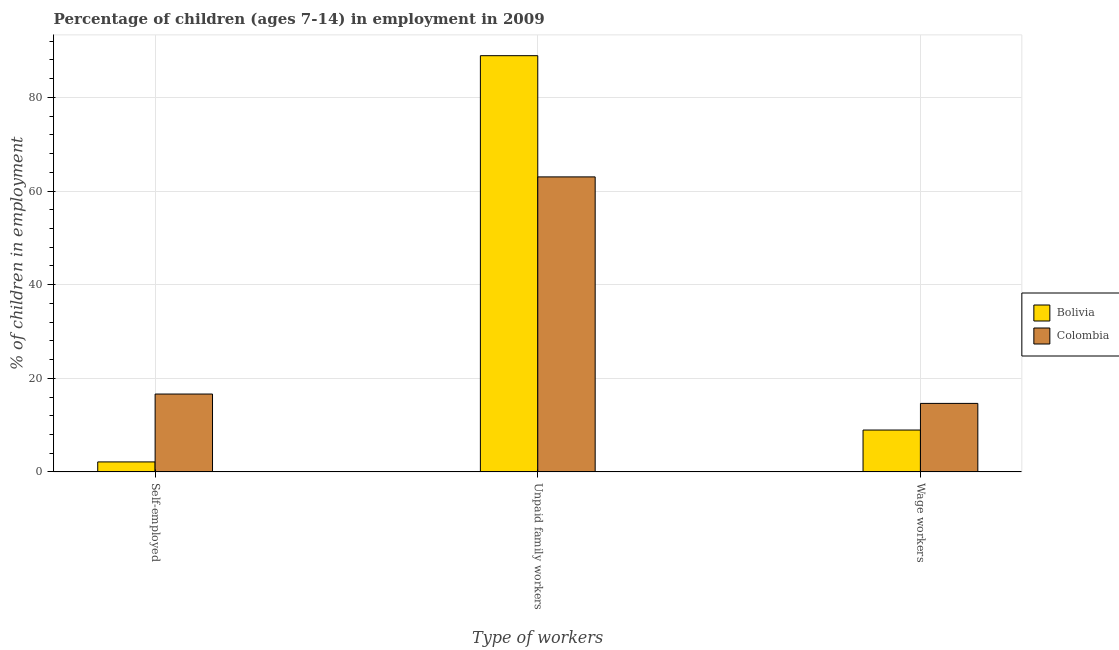How many different coloured bars are there?
Provide a succinct answer. 2. How many bars are there on the 1st tick from the left?
Offer a terse response. 2. What is the label of the 2nd group of bars from the left?
Keep it short and to the point. Unpaid family workers. What is the percentage of self employed children in Bolivia?
Keep it short and to the point. 2.14. Across all countries, what is the maximum percentage of self employed children?
Your response must be concise. 16.64. Across all countries, what is the minimum percentage of self employed children?
Provide a succinct answer. 2.14. In which country was the percentage of self employed children minimum?
Give a very brief answer. Bolivia. What is the total percentage of self employed children in the graph?
Your answer should be very brief. 18.78. What is the difference between the percentage of children employed as unpaid family workers in Bolivia and that in Colombia?
Offer a very short reply. 25.89. What is the difference between the percentage of children employed as wage workers in Bolivia and the percentage of self employed children in Colombia?
Your response must be concise. -7.69. What is the average percentage of children employed as unpaid family workers per country?
Make the answer very short. 75.97. What is the difference between the percentage of self employed children and percentage of children employed as wage workers in Bolivia?
Your response must be concise. -6.81. What is the ratio of the percentage of self employed children in Bolivia to that in Colombia?
Give a very brief answer. 0.13. What is the difference between the highest and the second highest percentage of children employed as wage workers?
Your response must be concise. 5.69. What is the difference between the highest and the lowest percentage of children employed as wage workers?
Offer a very short reply. 5.69. In how many countries, is the percentage of children employed as wage workers greater than the average percentage of children employed as wage workers taken over all countries?
Your answer should be very brief. 1. What does the 1st bar from the left in Self-employed represents?
Your response must be concise. Bolivia. How many bars are there?
Offer a very short reply. 6. Are all the bars in the graph horizontal?
Make the answer very short. No. How many countries are there in the graph?
Offer a very short reply. 2. Are the values on the major ticks of Y-axis written in scientific E-notation?
Your answer should be compact. No. Where does the legend appear in the graph?
Provide a succinct answer. Center right. How many legend labels are there?
Your response must be concise. 2. How are the legend labels stacked?
Keep it short and to the point. Vertical. What is the title of the graph?
Offer a terse response. Percentage of children (ages 7-14) in employment in 2009. What is the label or title of the X-axis?
Offer a terse response. Type of workers. What is the label or title of the Y-axis?
Your answer should be very brief. % of children in employment. What is the % of children in employment of Bolivia in Self-employed?
Your answer should be very brief. 2.14. What is the % of children in employment of Colombia in Self-employed?
Offer a very short reply. 16.64. What is the % of children in employment in Bolivia in Unpaid family workers?
Ensure brevity in your answer.  88.91. What is the % of children in employment in Colombia in Unpaid family workers?
Offer a terse response. 63.02. What is the % of children in employment of Bolivia in Wage workers?
Offer a very short reply. 8.95. What is the % of children in employment of Colombia in Wage workers?
Your response must be concise. 14.64. Across all Type of workers, what is the maximum % of children in employment of Bolivia?
Your answer should be very brief. 88.91. Across all Type of workers, what is the maximum % of children in employment of Colombia?
Offer a terse response. 63.02. Across all Type of workers, what is the minimum % of children in employment of Bolivia?
Provide a succinct answer. 2.14. Across all Type of workers, what is the minimum % of children in employment of Colombia?
Provide a short and direct response. 14.64. What is the total % of children in employment of Colombia in the graph?
Offer a very short reply. 94.3. What is the difference between the % of children in employment of Bolivia in Self-employed and that in Unpaid family workers?
Provide a short and direct response. -86.77. What is the difference between the % of children in employment of Colombia in Self-employed and that in Unpaid family workers?
Make the answer very short. -46.38. What is the difference between the % of children in employment of Bolivia in Self-employed and that in Wage workers?
Ensure brevity in your answer.  -6.81. What is the difference between the % of children in employment in Colombia in Self-employed and that in Wage workers?
Provide a succinct answer. 2. What is the difference between the % of children in employment in Bolivia in Unpaid family workers and that in Wage workers?
Give a very brief answer. 79.96. What is the difference between the % of children in employment in Colombia in Unpaid family workers and that in Wage workers?
Your answer should be very brief. 48.38. What is the difference between the % of children in employment in Bolivia in Self-employed and the % of children in employment in Colombia in Unpaid family workers?
Your answer should be compact. -60.88. What is the difference between the % of children in employment of Bolivia in Self-employed and the % of children in employment of Colombia in Wage workers?
Your answer should be very brief. -12.5. What is the difference between the % of children in employment in Bolivia in Unpaid family workers and the % of children in employment in Colombia in Wage workers?
Offer a very short reply. 74.27. What is the average % of children in employment in Bolivia per Type of workers?
Make the answer very short. 33.33. What is the average % of children in employment in Colombia per Type of workers?
Ensure brevity in your answer.  31.43. What is the difference between the % of children in employment in Bolivia and % of children in employment in Colombia in Unpaid family workers?
Make the answer very short. 25.89. What is the difference between the % of children in employment of Bolivia and % of children in employment of Colombia in Wage workers?
Make the answer very short. -5.69. What is the ratio of the % of children in employment of Bolivia in Self-employed to that in Unpaid family workers?
Your answer should be compact. 0.02. What is the ratio of the % of children in employment in Colombia in Self-employed to that in Unpaid family workers?
Your response must be concise. 0.26. What is the ratio of the % of children in employment of Bolivia in Self-employed to that in Wage workers?
Provide a short and direct response. 0.24. What is the ratio of the % of children in employment in Colombia in Self-employed to that in Wage workers?
Your response must be concise. 1.14. What is the ratio of the % of children in employment in Bolivia in Unpaid family workers to that in Wage workers?
Offer a terse response. 9.93. What is the ratio of the % of children in employment of Colombia in Unpaid family workers to that in Wage workers?
Offer a terse response. 4.3. What is the difference between the highest and the second highest % of children in employment of Bolivia?
Your response must be concise. 79.96. What is the difference between the highest and the second highest % of children in employment of Colombia?
Offer a very short reply. 46.38. What is the difference between the highest and the lowest % of children in employment of Bolivia?
Give a very brief answer. 86.77. What is the difference between the highest and the lowest % of children in employment of Colombia?
Keep it short and to the point. 48.38. 